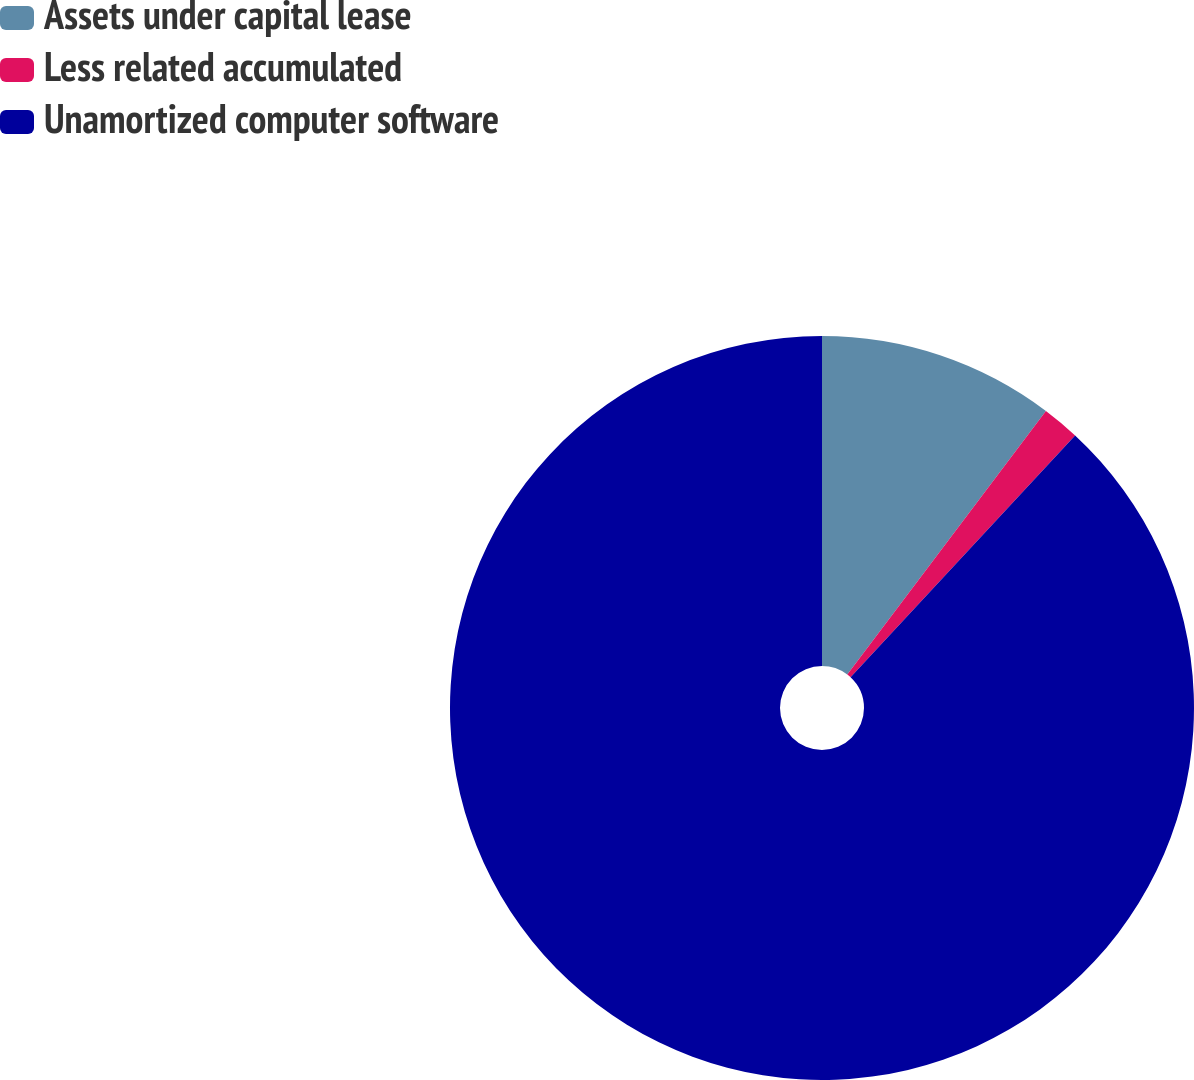<chart> <loc_0><loc_0><loc_500><loc_500><pie_chart><fcel>Assets under capital lease<fcel>Less related accumulated<fcel>Unamortized computer software<nl><fcel>10.28%<fcel>1.63%<fcel>88.09%<nl></chart> 